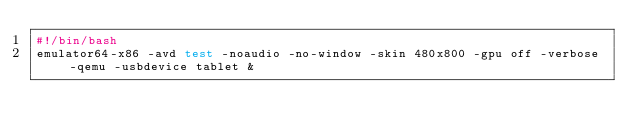<code> <loc_0><loc_0><loc_500><loc_500><_Bash_>#!/bin/bash
emulator64-x86 -avd test -noaudio -no-window -skin 480x800 -gpu off -verbose -qemu -usbdevice tablet &
</code> 